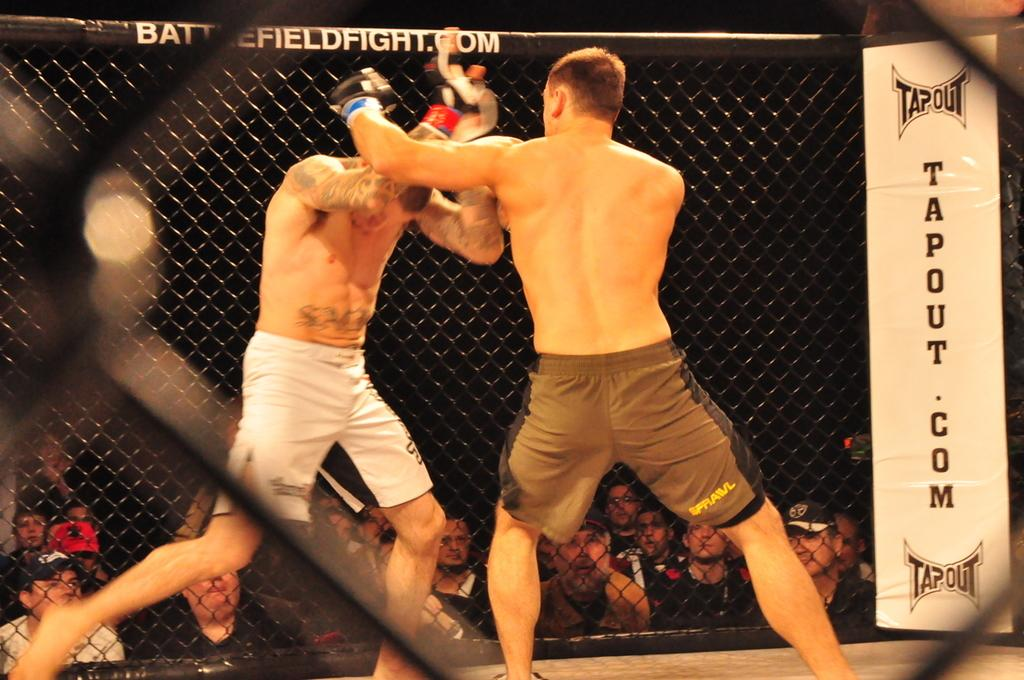What are the two men in the image doing? The two men in the image are fighting. What else can be seen in the image besides the men fighting? There is a banner and mesh in the image. Can you describe the mesh in the image? The mesh is a type of material that allows people to be visible through it. What is the condition of the background in the image? The background of the image is dark. What type of punishment is being given to the man who is laughing in the image? There is no man laughing in the image, and therefore no punishment can be observed. How many dimes are visible on the banner in the image? There are no dimes present on the banner in the image. 